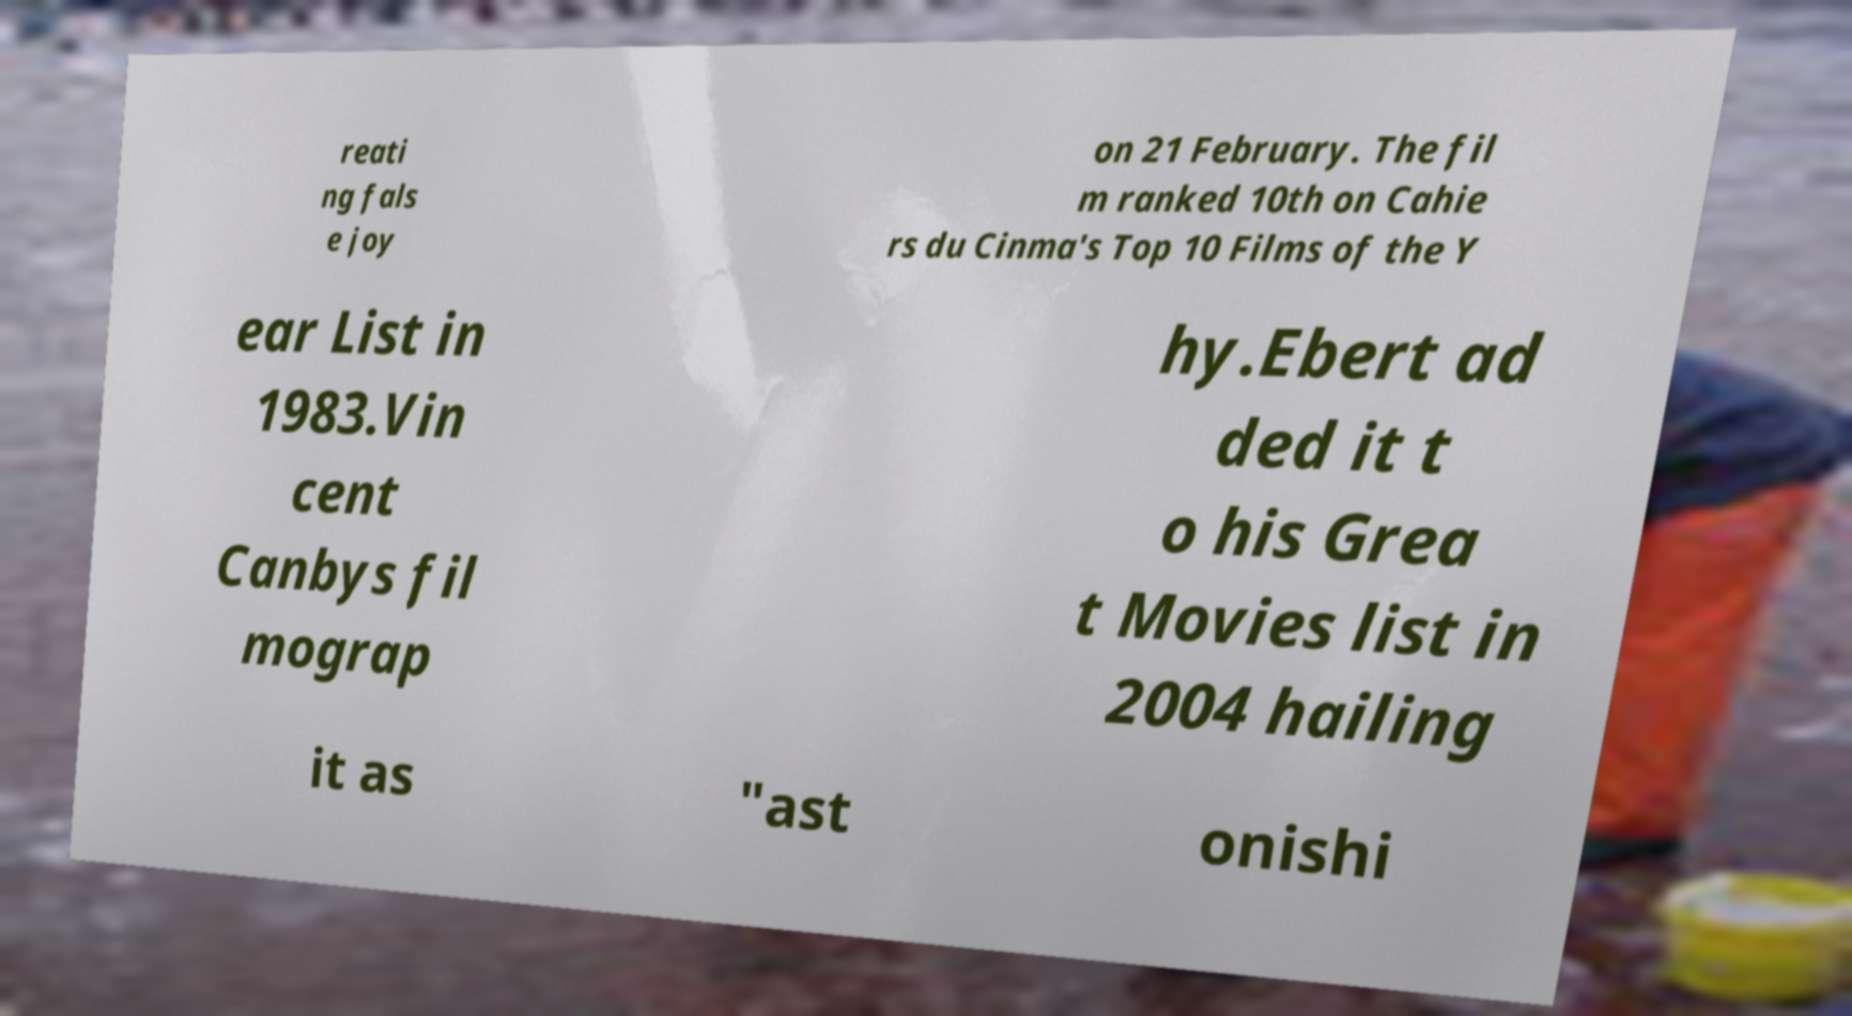Could you extract and type out the text from this image? reati ng fals e joy on 21 February. The fil m ranked 10th on Cahie rs du Cinma's Top 10 Films of the Y ear List in 1983.Vin cent Canbys fil mograp hy.Ebert ad ded it t o his Grea t Movies list in 2004 hailing it as "ast onishi 